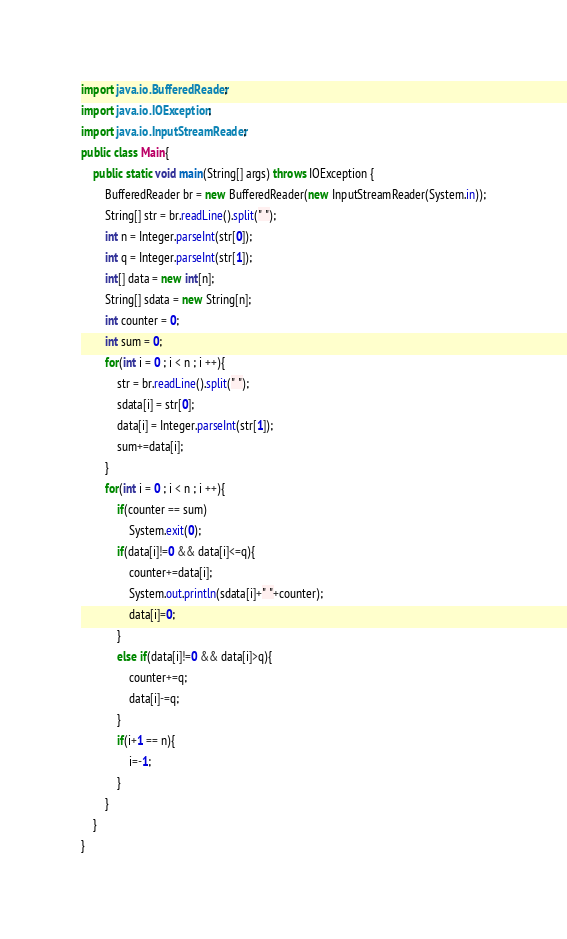Convert code to text. <code><loc_0><loc_0><loc_500><loc_500><_Java_>import java.io.BufferedReader;
import java.io.IOException;
import java.io.InputStreamReader;
public class Main{
	public static void main(String[] args) throws IOException {
		BufferedReader br = new BufferedReader(new InputStreamReader(System.in));
		String[] str = br.readLine().split(" ");
		int n = Integer.parseInt(str[0]);
		int q = Integer.parseInt(str[1]);
		int[] data = new int[n];
		String[] sdata = new String[n];
		int counter = 0;
		int sum = 0;
		for(int i = 0 ; i < n ; i ++){
			str = br.readLine().split(" ");
			sdata[i] = str[0];
			data[i] = Integer.parseInt(str[1]);
			sum+=data[i];
		}
		for(int i = 0 ; i < n ; i ++){
			if(counter == sum)
				System.exit(0);
			if(data[i]!=0 && data[i]<=q){
				counter+=data[i];
				System.out.println(sdata[i]+" "+counter);
				data[i]=0;
			}
			else if(data[i]!=0 && data[i]>q){
				counter+=q;
				data[i]-=q;
			}
			if(i+1 == n){
				i=-1;
			}
		}
	}
}</code> 